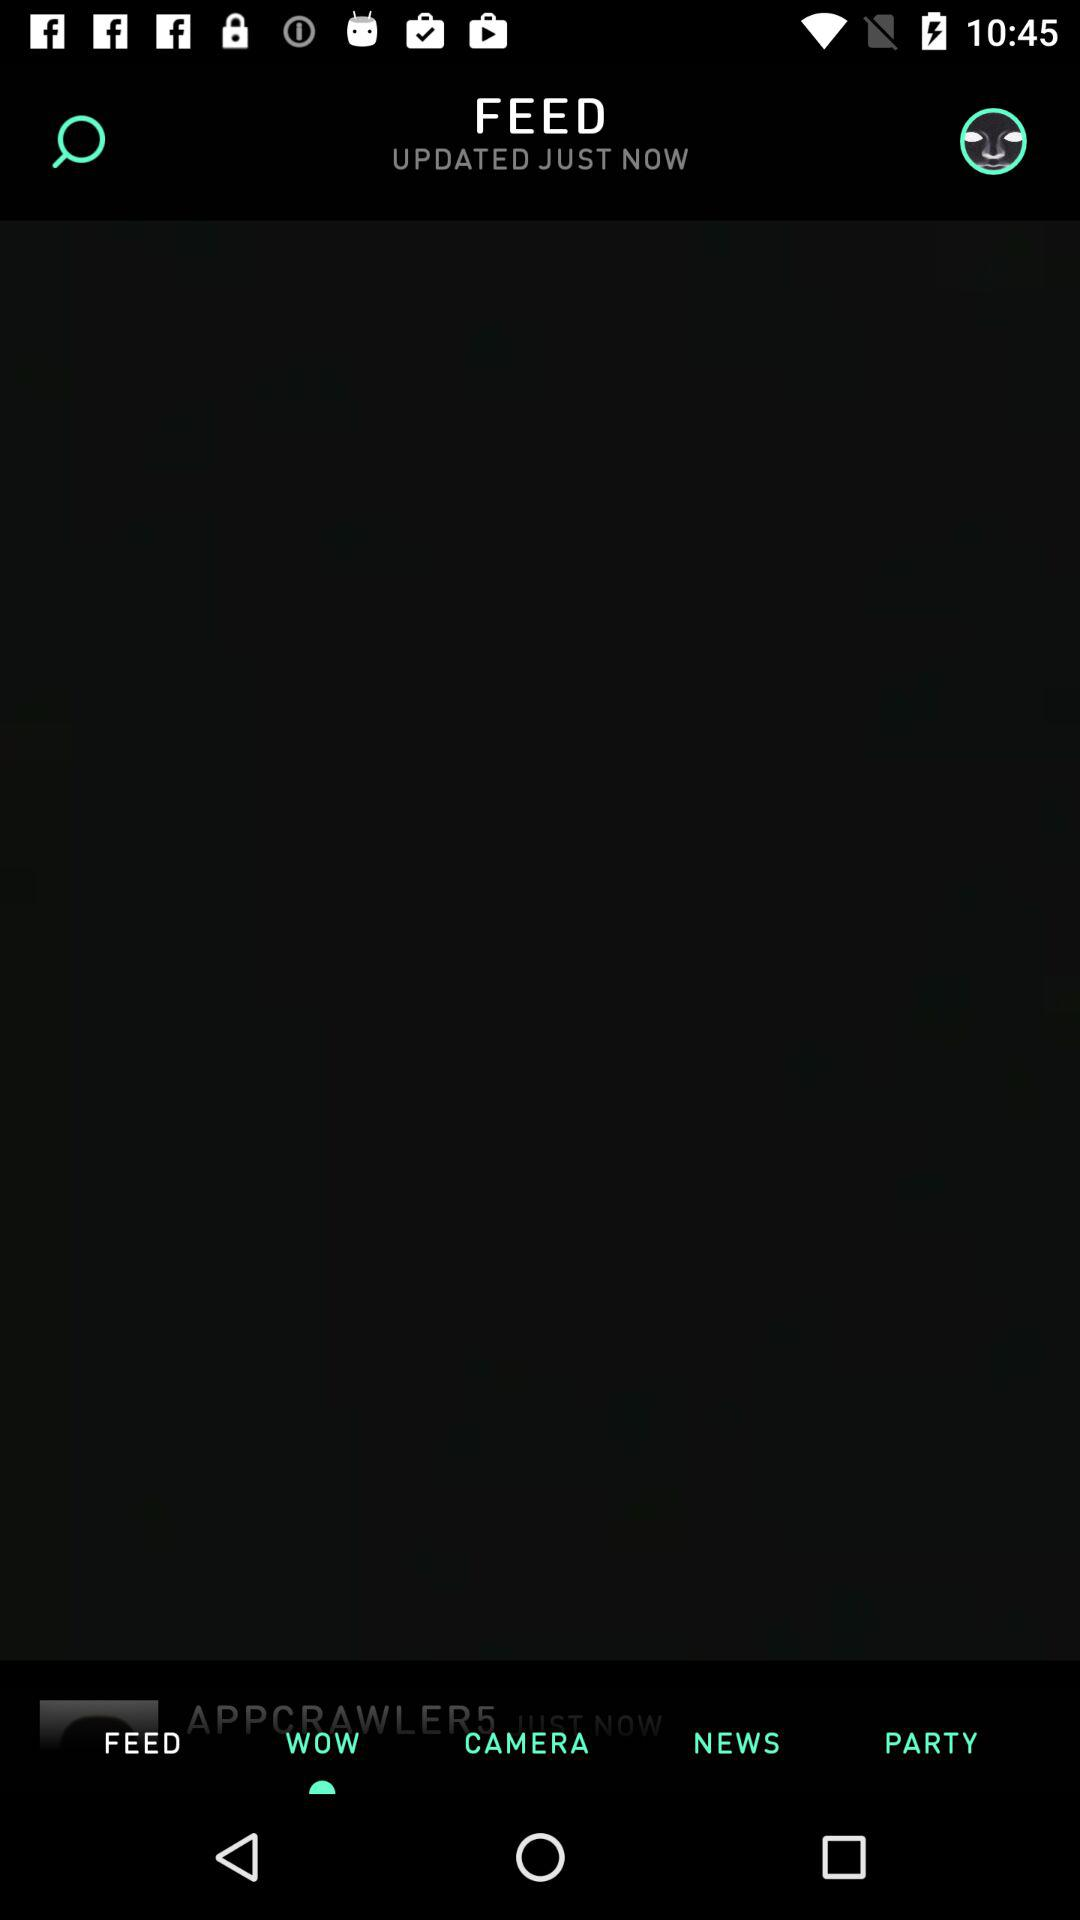When was the feed updated? The feed was updated just now. 